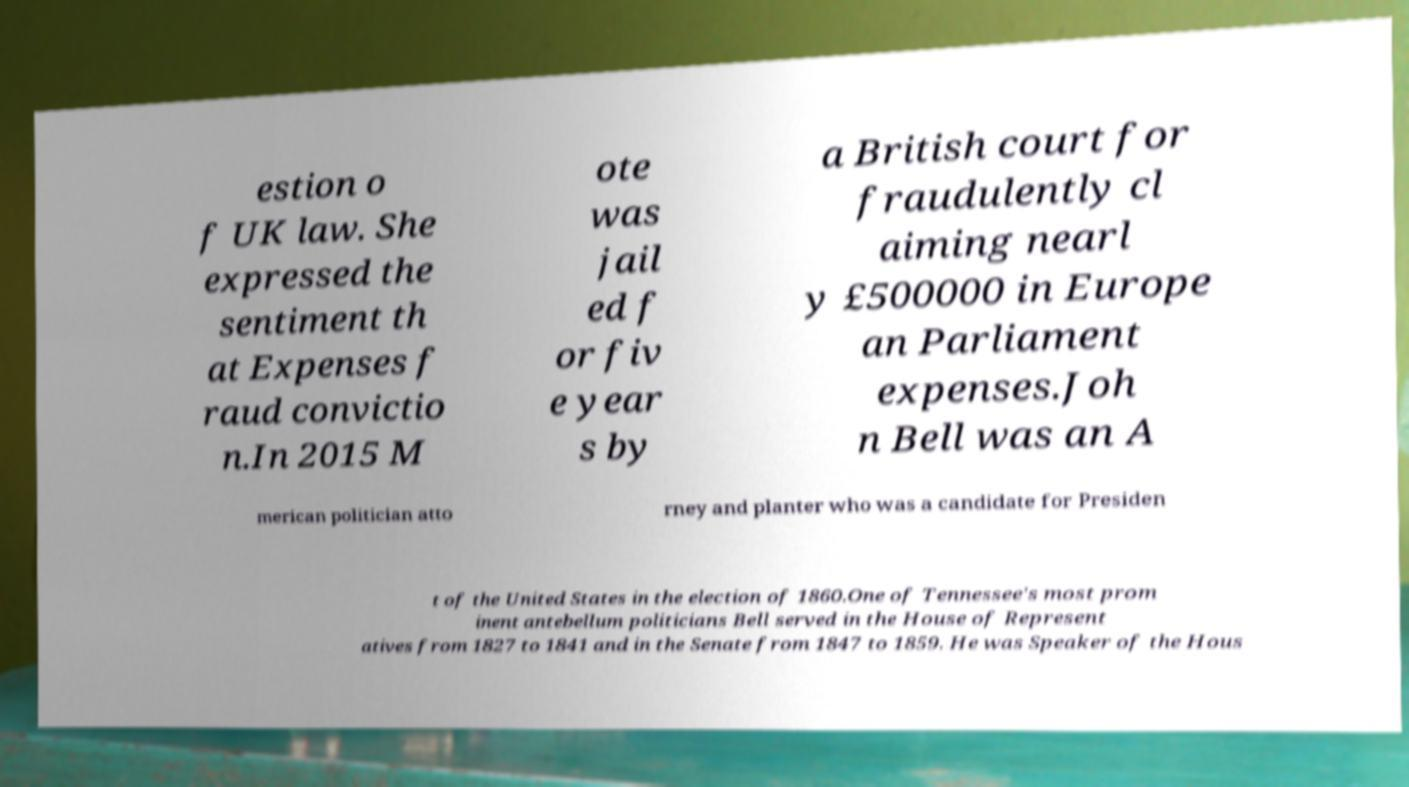Can you read and provide the text displayed in the image?This photo seems to have some interesting text. Can you extract and type it out for me? estion o f UK law. She expressed the sentiment th at Expenses f raud convictio n.In 2015 M ote was jail ed f or fiv e year s by a British court for fraudulently cl aiming nearl y £500000 in Europe an Parliament expenses.Joh n Bell was an A merican politician atto rney and planter who was a candidate for Presiden t of the United States in the election of 1860.One of Tennessee's most prom inent antebellum politicians Bell served in the House of Represent atives from 1827 to 1841 and in the Senate from 1847 to 1859. He was Speaker of the Hous 